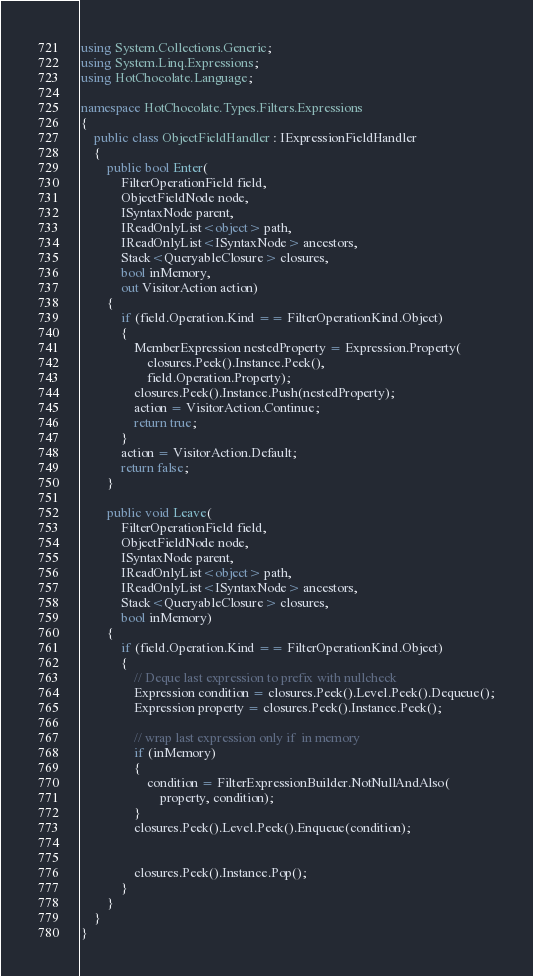Convert code to text. <code><loc_0><loc_0><loc_500><loc_500><_C#_>using System.Collections.Generic;
using System.Linq.Expressions;
using HotChocolate.Language;

namespace HotChocolate.Types.Filters.Expressions
{
    public class ObjectFieldHandler : IExpressionFieldHandler
    {
        public bool Enter(
            FilterOperationField field,
            ObjectFieldNode node,
            ISyntaxNode parent,
            IReadOnlyList<object> path,
            IReadOnlyList<ISyntaxNode> ancestors,
            Stack<QueryableClosure> closures,
            bool inMemory,
            out VisitorAction action)
        {
            if (field.Operation.Kind == FilterOperationKind.Object)
            {
                MemberExpression nestedProperty = Expression.Property(
                    closures.Peek().Instance.Peek(),
                    field.Operation.Property);
                closures.Peek().Instance.Push(nestedProperty);
                action = VisitorAction.Continue;
                return true;
            }
            action = VisitorAction.Default;
            return false;
        }

        public void Leave(
            FilterOperationField field,
            ObjectFieldNode node,
            ISyntaxNode parent,
            IReadOnlyList<object> path,
            IReadOnlyList<ISyntaxNode> ancestors,
            Stack<QueryableClosure> closures,
            bool inMemory)
        {
            if (field.Operation.Kind == FilterOperationKind.Object)
            {
                // Deque last expression to prefix with nullcheck
                Expression condition = closures.Peek().Level.Peek().Dequeue();
                Expression property = closures.Peek().Instance.Peek();

                // wrap last expression only if  in memory
                if (inMemory)
                {
                    condition = FilterExpressionBuilder.NotNullAndAlso(
                        property, condition);
                }
                closures.Peek().Level.Peek().Enqueue(condition);


                closures.Peek().Instance.Pop();
            }
        }
    }
}
</code> 